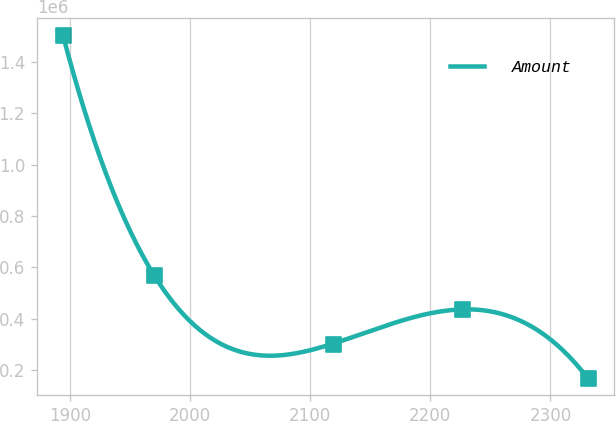<chart> <loc_0><loc_0><loc_500><loc_500><line_chart><ecel><fcel>Amount<nl><fcel>1894.36<fcel>1.50196e+06<nl><fcel>1970.12<fcel>570140<nl><fcel>2119.13<fcel>303907<nl><fcel>2226.41<fcel>437024<nl><fcel>2330.88<fcel>170790<nl></chart> 